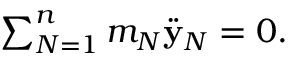Convert formula to latex. <formula><loc_0><loc_0><loc_500><loc_500>\begin{array} { r } { \sum _ { N = 1 } ^ { n } m _ { N } \ddot { y } _ { N } = 0 . } \end{array}</formula> 